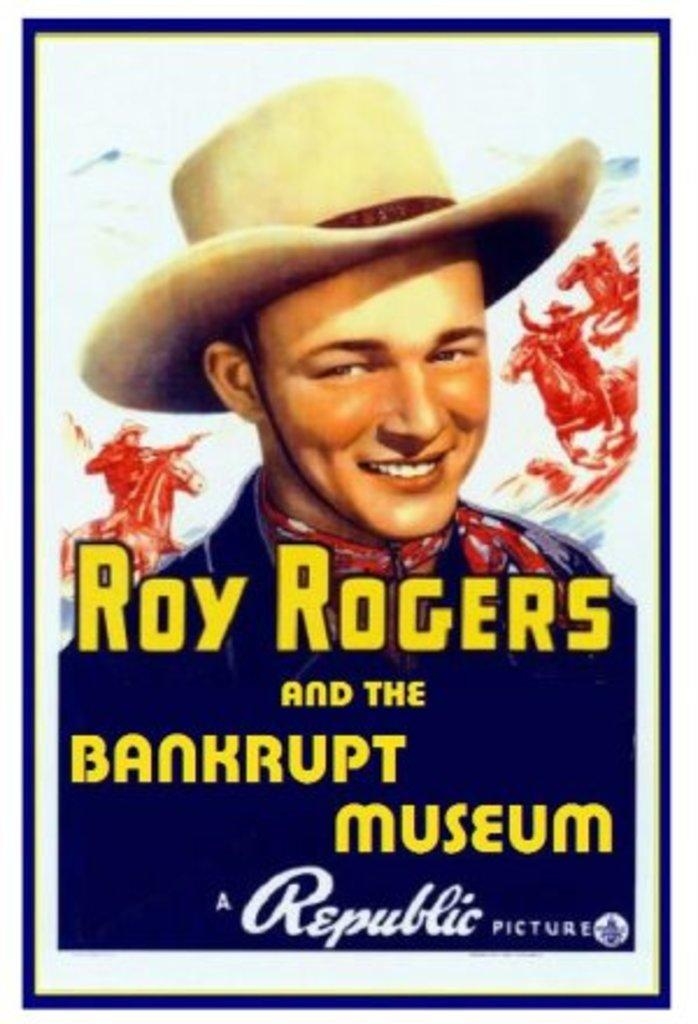<image>
Render a clear and concise summary of the photo. A poster for Roy Rogers and the Bankrupt Museum. 